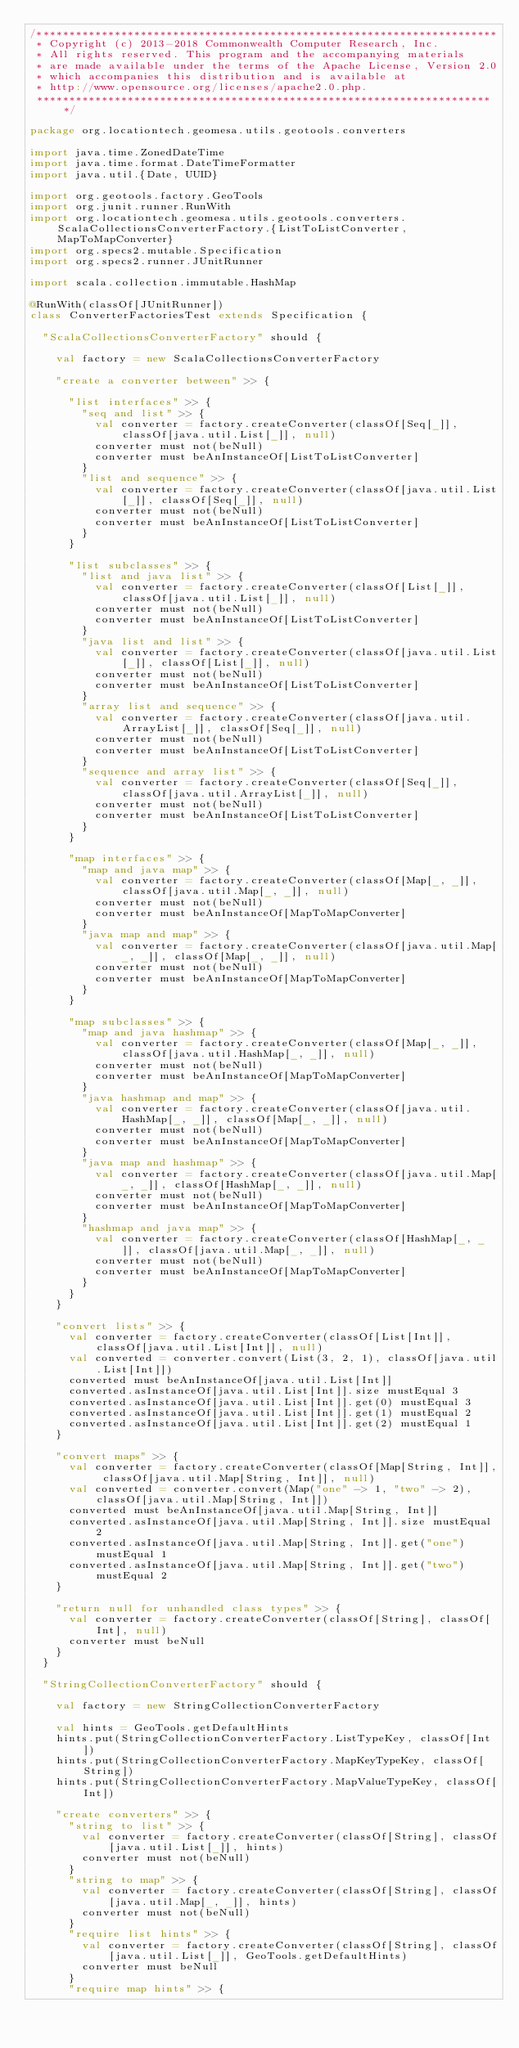Convert code to text. <code><loc_0><loc_0><loc_500><loc_500><_Scala_>/***********************************************************************
 * Copyright (c) 2013-2018 Commonwealth Computer Research, Inc.
 * All rights reserved. This program and the accompanying materials
 * are made available under the terms of the Apache License, Version 2.0
 * which accompanies this distribution and is available at
 * http://www.opensource.org/licenses/apache2.0.php.
 ***********************************************************************/

package org.locationtech.geomesa.utils.geotools.converters

import java.time.ZonedDateTime
import java.time.format.DateTimeFormatter
import java.util.{Date, UUID}

import org.geotools.factory.GeoTools
import org.junit.runner.RunWith
import org.locationtech.geomesa.utils.geotools.converters.ScalaCollectionsConverterFactory.{ListToListConverter, MapToMapConverter}
import org.specs2.mutable.Specification
import org.specs2.runner.JUnitRunner

import scala.collection.immutable.HashMap

@RunWith(classOf[JUnitRunner])
class ConverterFactoriesTest extends Specification {

  "ScalaCollectionsConverterFactory" should {

    val factory = new ScalaCollectionsConverterFactory

    "create a converter between" >> {

      "list interfaces" >> {
        "seq and list" >> {
          val converter = factory.createConverter(classOf[Seq[_]], classOf[java.util.List[_]], null)
          converter must not(beNull)
          converter must beAnInstanceOf[ListToListConverter]
        }
        "list and sequence" >> {
          val converter = factory.createConverter(classOf[java.util.List[_]], classOf[Seq[_]], null)
          converter must not(beNull)
          converter must beAnInstanceOf[ListToListConverter]
        }
      }

      "list subclasses" >> {
        "list and java list" >> {
          val converter = factory.createConverter(classOf[List[_]], classOf[java.util.List[_]], null)
          converter must not(beNull)
          converter must beAnInstanceOf[ListToListConverter]
        }
        "java list and list" >> {
          val converter = factory.createConverter(classOf[java.util.List[_]], classOf[List[_]], null)
          converter must not(beNull)
          converter must beAnInstanceOf[ListToListConverter]
        }
        "array list and sequence" >> {
          val converter = factory.createConverter(classOf[java.util.ArrayList[_]], classOf[Seq[_]], null)
          converter must not(beNull)
          converter must beAnInstanceOf[ListToListConverter]
        }
        "sequence and array list" >> {
          val converter = factory.createConverter(classOf[Seq[_]], classOf[java.util.ArrayList[_]], null)
          converter must not(beNull)
          converter must beAnInstanceOf[ListToListConverter]
        }
      }

      "map interfaces" >> {
        "map and java map" >> {
          val converter = factory.createConverter(classOf[Map[_, _]], classOf[java.util.Map[_, _]], null)
          converter must not(beNull)
          converter must beAnInstanceOf[MapToMapConverter]
        }
        "java map and map" >> {
          val converter = factory.createConverter(classOf[java.util.Map[_, _]], classOf[Map[_, _]], null)
          converter must not(beNull)
          converter must beAnInstanceOf[MapToMapConverter]
        }
      }

      "map subclasses" >> {
        "map and java hashmap" >> {
          val converter = factory.createConverter(classOf[Map[_, _]], classOf[java.util.HashMap[_, _]], null)
          converter must not(beNull)
          converter must beAnInstanceOf[MapToMapConverter]
        }
        "java hashmap and map" >> {
          val converter = factory.createConverter(classOf[java.util.HashMap[_, _]], classOf[Map[_, _]], null)
          converter must not(beNull)
          converter must beAnInstanceOf[MapToMapConverter]
        }
        "java map and hashmap" >> {
          val converter = factory.createConverter(classOf[java.util.Map[_, _]], classOf[HashMap[_, _]], null)
          converter must not(beNull)
          converter must beAnInstanceOf[MapToMapConverter]
        }
        "hashmap and java map" >> {
          val converter = factory.createConverter(classOf[HashMap[_, _]], classOf[java.util.Map[_, _]], null)
          converter must not(beNull)
          converter must beAnInstanceOf[MapToMapConverter]
        }
      }
    }

    "convert lists" >> {
      val converter = factory.createConverter(classOf[List[Int]], classOf[java.util.List[Int]], null)
      val converted = converter.convert(List(3, 2, 1), classOf[java.util.List[Int]])
      converted must beAnInstanceOf[java.util.List[Int]]
      converted.asInstanceOf[java.util.List[Int]].size mustEqual 3
      converted.asInstanceOf[java.util.List[Int]].get(0) mustEqual 3
      converted.asInstanceOf[java.util.List[Int]].get(1) mustEqual 2
      converted.asInstanceOf[java.util.List[Int]].get(2) mustEqual 1
    }

    "convert maps" >> {
      val converter = factory.createConverter(classOf[Map[String, Int]], classOf[java.util.Map[String, Int]], null)
      val converted = converter.convert(Map("one" -> 1, "two" -> 2), classOf[java.util.Map[String, Int]])
      converted must beAnInstanceOf[java.util.Map[String, Int]]
      converted.asInstanceOf[java.util.Map[String, Int]].size mustEqual 2
      converted.asInstanceOf[java.util.Map[String, Int]].get("one") mustEqual 1
      converted.asInstanceOf[java.util.Map[String, Int]].get("two") mustEqual 2
    }

    "return null for unhandled class types" >> {
      val converter = factory.createConverter(classOf[String], classOf[Int], null)
      converter must beNull
    }
  }

  "StringCollectionConverterFactory" should {

    val factory = new StringCollectionConverterFactory

    val hints = GeoTools.getDefaultHints
    hints.put(StringCollectionConverterFactory.ListTypeKey, classOf[Int])
    hints.put(StringCollectionConverterFactory.MapKeyTypeKey, classOf[String])
    hints.put(StringCollectionConverterFactory.MapValueTypeKey, classOf[Int])

    "create converters" >> {
      "string to list" >> {
        val converter = factory.createConverter(classOf[String], classOf[java.util.List[_]], hints)
        converter must not(beNull)
      }
      "string to map" >> {
        val converter = factory.createConverter(classOf[String], classOf[java.util.Map[_, _]], hints)
        converter must not(beNull)
      }
      "require list hints" >> {
        val converter = factory.createConverter(classOf[String], classOf[java.util.List[_]], GeoTools.getDefaultHints)
        converter must beNull
      }
      "require map hints" >> {</code> 